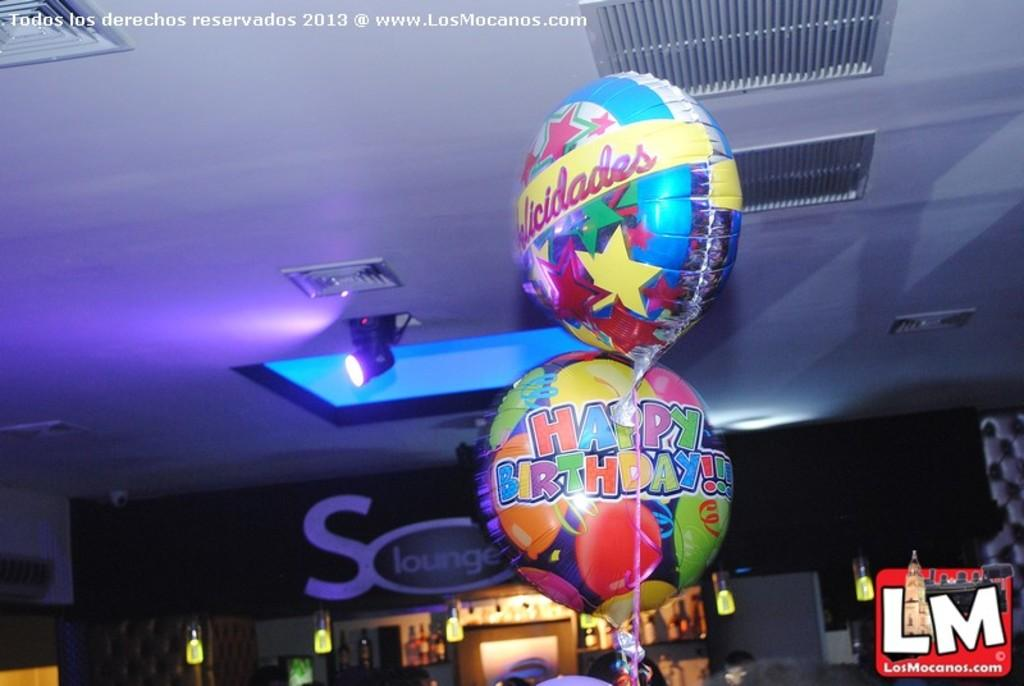<image>
Give a short and clear explanation of the subsequent image. A colorful balloon displays the message happy birthday on it. 